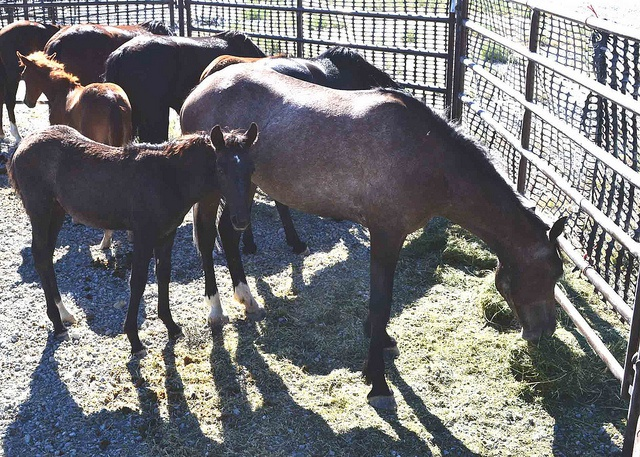Describe the objects in this image and their specific colors. I can see horse in gray, black, and white tones, horse in gray, black, and white tones, horse in gray, black, white, and darkgray tones, horse in gray, black, and ivory tones, and horse in gray, black, and white tones in this image. 